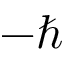<formula> <loc_0><loc_0><loc_500><loc_500>- \hbar</formula> 